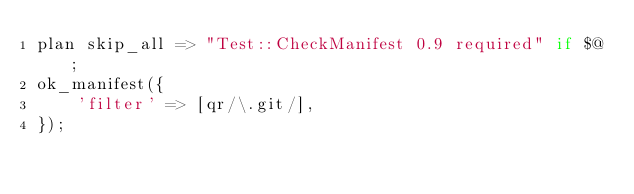<code> <loc_0><loc_0><loc_500><loc_500><_Perl_>plan skip_all => "Test::CheckManifest 0.9 required" if $@;
ok_manifest({
    'filter' => [qr/\.git/],
});

</code> 